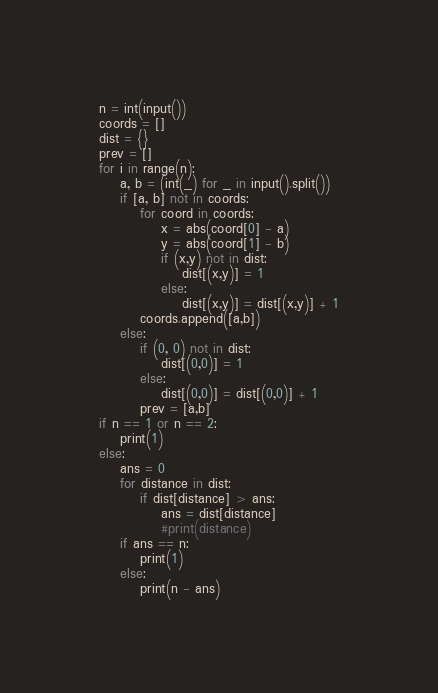<code> <loc_0><loc_0><loc_500><loc_500><_Python_>n = int(input())
coords = []
dist = {}
prev = []
for i in range(n):
    a, b = (int(_) for _ in input().split())
    if [a, b] not in coords:
        for coord in coords:
            x = abs(coord[0] - a)
            y = abs(coord[1] - b)
            if (x,y) not in dist:
                dist[(x,y)] = 1
            else:
                dist[(x,y)] = dist[(x,y)] + 1
        coords.append([a,b])
    else:
        if (0, 0) not in dist:
            dist[(0,0)] = 1
        else:
            dist[(0,0)] = dist[(0,0)] + 1
        prev = [a,b]
if n == 1 or n == 2:
    print(1)
else:
    ans = 0
    for distance in dist:
        if dist[distance] > ans:
            ans = dist[distance]
            #print(distance)
    if ans == n:
        print(1)
    else:
        print(n - ans)</code> 